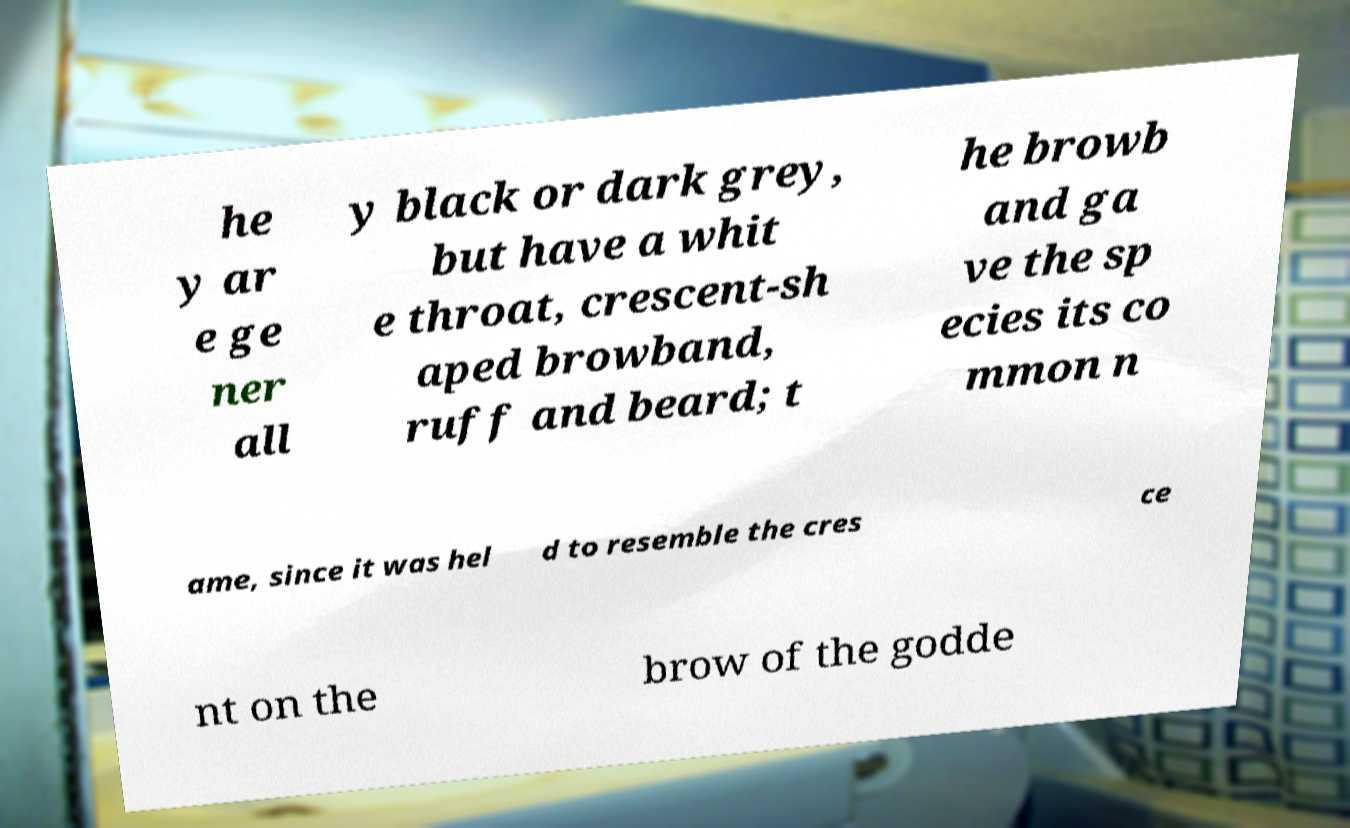Can you read and provide the text displayed in the image?This photo seems to have some interesting text. Can you extract and type it out for me? he y ar e ge ner all y black or dark grey, but have a whit e throat, crescent-sh aped browband, ruff and beard; t he browb and ga ve the sp ecies its co mmon n ame, since it was hel d to resemble the cres ce nt on the brow of the godde 